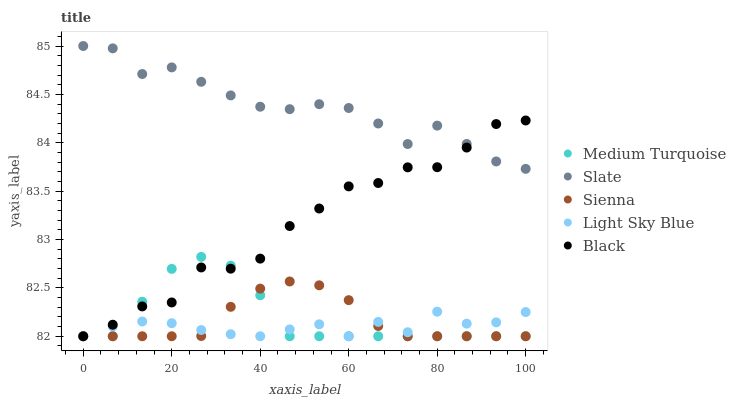Does Light Sky Blue have the minimum area under the curve?
Answer yes or no. Yes. Does Slate have the maximum area under the curve?
Answer yes or no. Yes. Does Slate have the minimum area under the curve?
Answer yes or no. No. Does Light Sky Blue have the maximum area under the curve?
Answer yes or no. No. Is Sienna the smoothest?
Answer yes or no. Yes. Is Black the roughest?
Answer yes or no. Yes. Is Slate the smoothest?
Answer yes or no. No. Is Slate the roughest?
Answer yes or no. No. Does Sienna have the lowest value?
Answer yes or no. Yes. Does Slate have the lowest value?
Answer yes or no. No. Does Slate have the highest value?
Answer yes or no. Yes. Does Light Sky Blue have the highest value?
Answer yes or no. No. Is Medium Turquoise less than Slate?
Answer yes or no. Yes. Is Slate greater than Medium Turquoise?
Answer yes or no. Yes. Does Black intersect Medium Turquoise?
Answer yes or no. Yes. Is Black less than Medium Turquoise?
Answer yes or no. No. Is Black greater than Medium Turquoise?
Answer yes or no. No. Does Medium Turquoise intersect Slate?
Answer yes or no. No. 